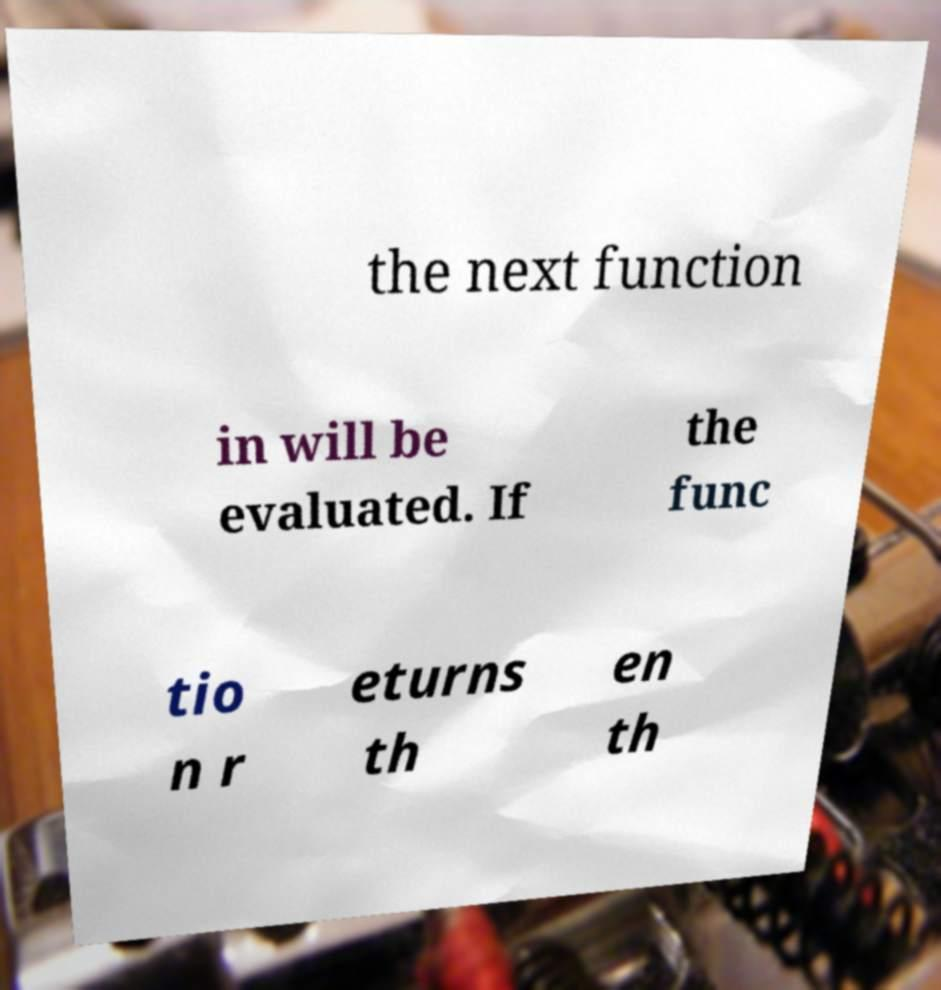Can you accurately transcribe the text from the provided image for me? the next function in will be evaluated. If the func tio n r eturns th en th 